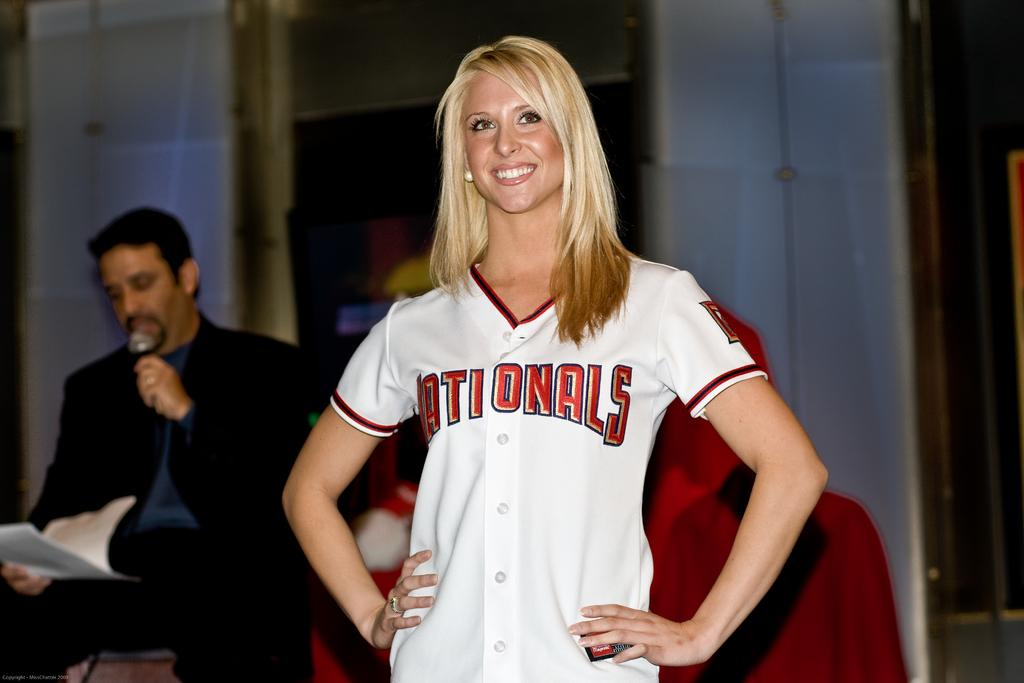<image>
Describe the image concisely. A blonde woman poses proudly in a Nationals jersey 